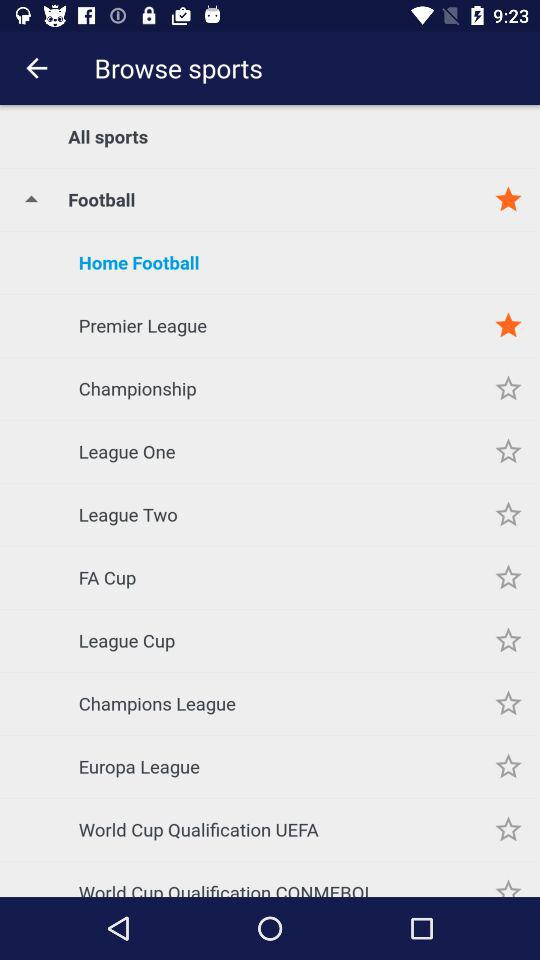Which sport is mentioned? The mentioned sport is "Football". 